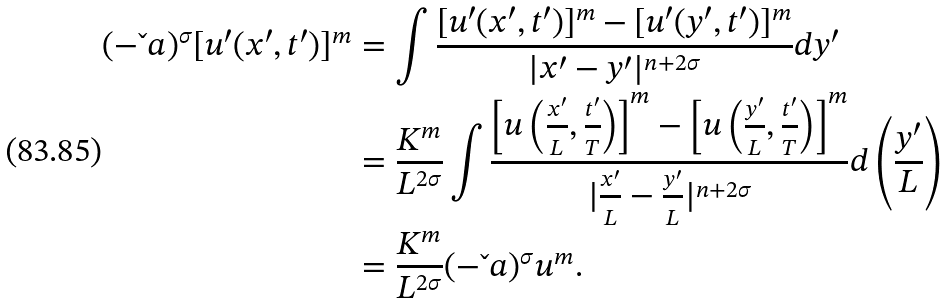Convert formula to latex. <formula><loc_0><loc_0><loc_500><loc_500>( - \L a ) ^ { \sigma } [ u ^ { \prime } ( x ^ { \prime } , t ^ { \prime } ) ] ^ { m } & = \int \frac { [ u ^ { \prime } ( x ^ { \prime } , t ^ { \prime } ) ] ^ { m } - [ u ^ { \prime } ( y ^ { \prime } , t ^ { \prime } ) ] ^ { m } } { | x ^ { \prime } - y ^ { \prime } | ^ { n + 2 \sigma } } d y ^ { \prime } \\ & = \frac { K ^ { m } } { L ^ { 2 \sigma } } \int \frac { \left [ u \left ( \frac { x ^ { \prime } } { L } , \frac { t ^ { \prime } } { T } \right ) \right ] ^ { m } - \left [ u \left ( \frac { y ^ { \prime } } { L } , \frac { t ^ { \prime } } { T } \right ) \right ] ^ { m } } { | \frac { x ^ { \prime } } { L } - \frac { y ^ { \prime } } { L } | ^ { n + 2 \sigma } } d \left ( \frac { y ^ { \prime } } { L } \right ) \\ & = \frac { K ^ { m } } { L ^ { 2 \sigma } } ( - \L a ) ^ { \sigma } u ^ { m } .</formula> 